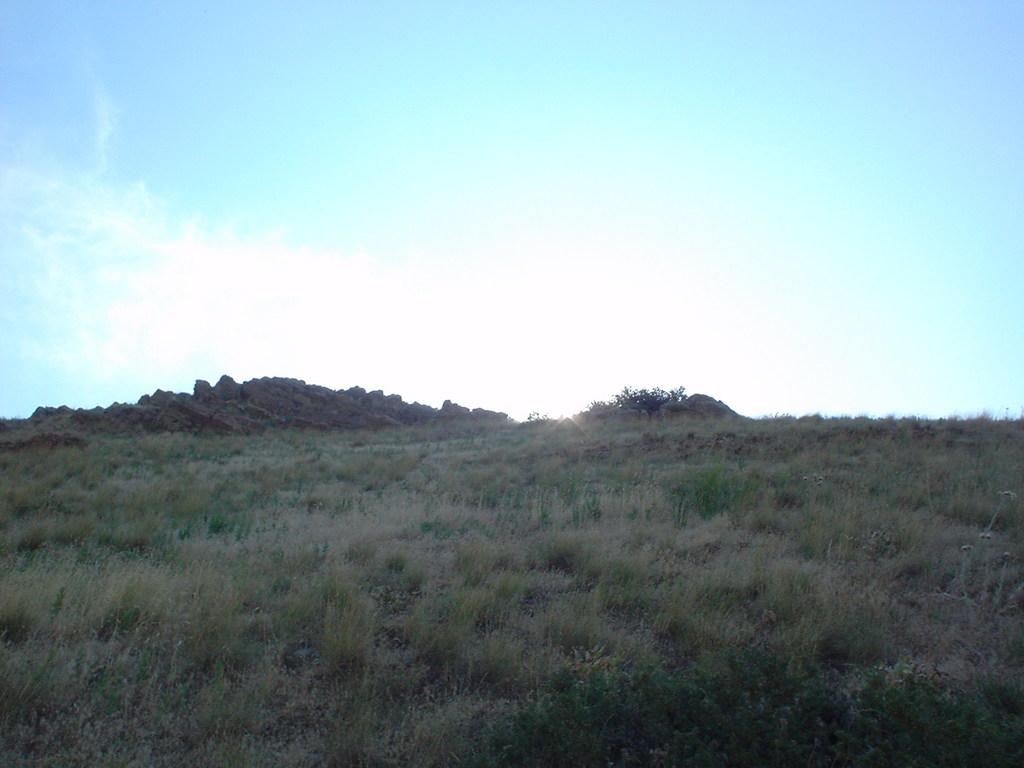What type of landscape is depicted in the image? There is a grassland in the image. What geographical feature can be seen in the image? There is a hill in the image. What is visible in the background of the image? The sky is visible in the background of the image. Where is the dock located in the image? There is no dock present in the image. What type of beef is being prepared in the image? There is no beef or any food preparation visible in the image. 